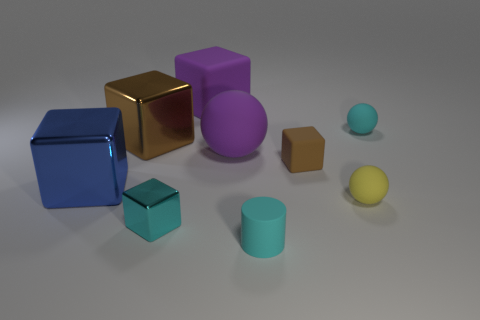Subtract all blue cylinders. How many brown cubes are left? 2 Subtract all small metal blocks. How many blocks are left? 4 Subtract all blue cubes. How many cubes are left? 4 Add 1 big brown matte cylinders. How many objects exist? 10 Subtract all blue balls. Subtract all blue cylinders. How many balls are left? 3 Subtract 1 blue blocks. How many objects are left? 8 Subtract all spheres. How many objects are left? 6 Subtract all small cyan shiny things. Subtract all purple things. How many objects are left? 6 Add 1 big things. How many big things are left? 5 Add 9 green matte cylinders. How many green matte cylinders exist? 9 